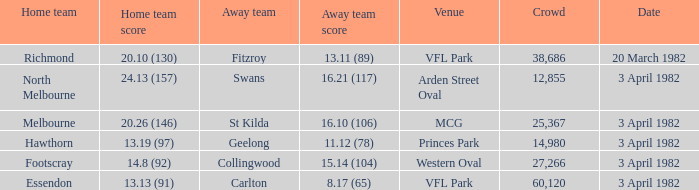Would you mind parsing the complete table? {'header': ['Home team', 'Home team score', 'Away team', 'Away team score', 'Venue', 'Crowd', 'Date'], 'rows': [['Richmond', '20.10 (130)', 'Fitzroy', '13.11 (89)', 'VFL Park', '38,686', '20 March 1982'], ['North Melbourne', '24.13 (157)', 'Swans', '16.21 (117)', 'Arden Street Oval', '12,855', '3 April 1982'], ['Melbourne', '20.26 (146)', 'St Kilda', '16.10 (106)', 'MCG', '25,367', '3 April 1982'], ['Hawthorn', '13.19 (97)', 'Geelong', '11.12 (78)', 'Princes Park', '14,980', '3 April 1982'], ['Footscray', '14.8 (92)', 'Collingwood', '15.14 (104)', 'Western Oval', '27,266', '3 April 1982'], ['Essendon', '13.13 (91)', 'Carlton', '8.17 (65)', 'VFL Park', '60,120', '3 April 1982']]} When the away team scored 16.21 (117), what was the home teams score? 24.13 (157). 